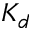<formula> <loc_0><loc_0><loc_500><loc_500>K _ { d }</formula> 